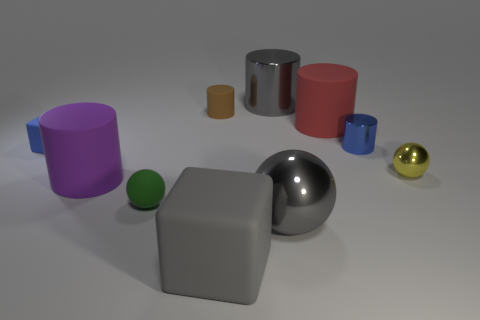What number of other things are there of the same color as the big block?
Your answer should be very brief. 2. There is a purple cylinder; are there any big things on the left side of it?
Give a very brief answer. No. What number of objects are either blue metallic balls or small balls that are in front of the yellow object?
Your answer should be compact. 1. There is a cube that is behind the big gray rubber cube; are there any tiny green objects behind it?
Ensure brevity in your answer.  No. What shape is the big gray object that is right of the gray thing that is behind the large matte cylinder behind the purple rubber thing?
Keep it short and to the point. Sphere. What is the color of the small thing that is both behind the small block and to the left of the large red cylinder?
Offer a terse response. Brown. What shape is the large gray metal object that is behind the tiny matte cube?
Provide a succinct answer. Cylinder. There is a tiny green object that is the same material as the small brown cylinder; what shape is it?
Provide a short and direct response. Sphere. What number of rubber objects are either small brown objects or tiny balls?
Your answer should be compact. 2. There is a large matte object that is behind the tiny ball behind the large purple cylinder; how many large blocks are right of it?
Provide a short and direct response. 0. 